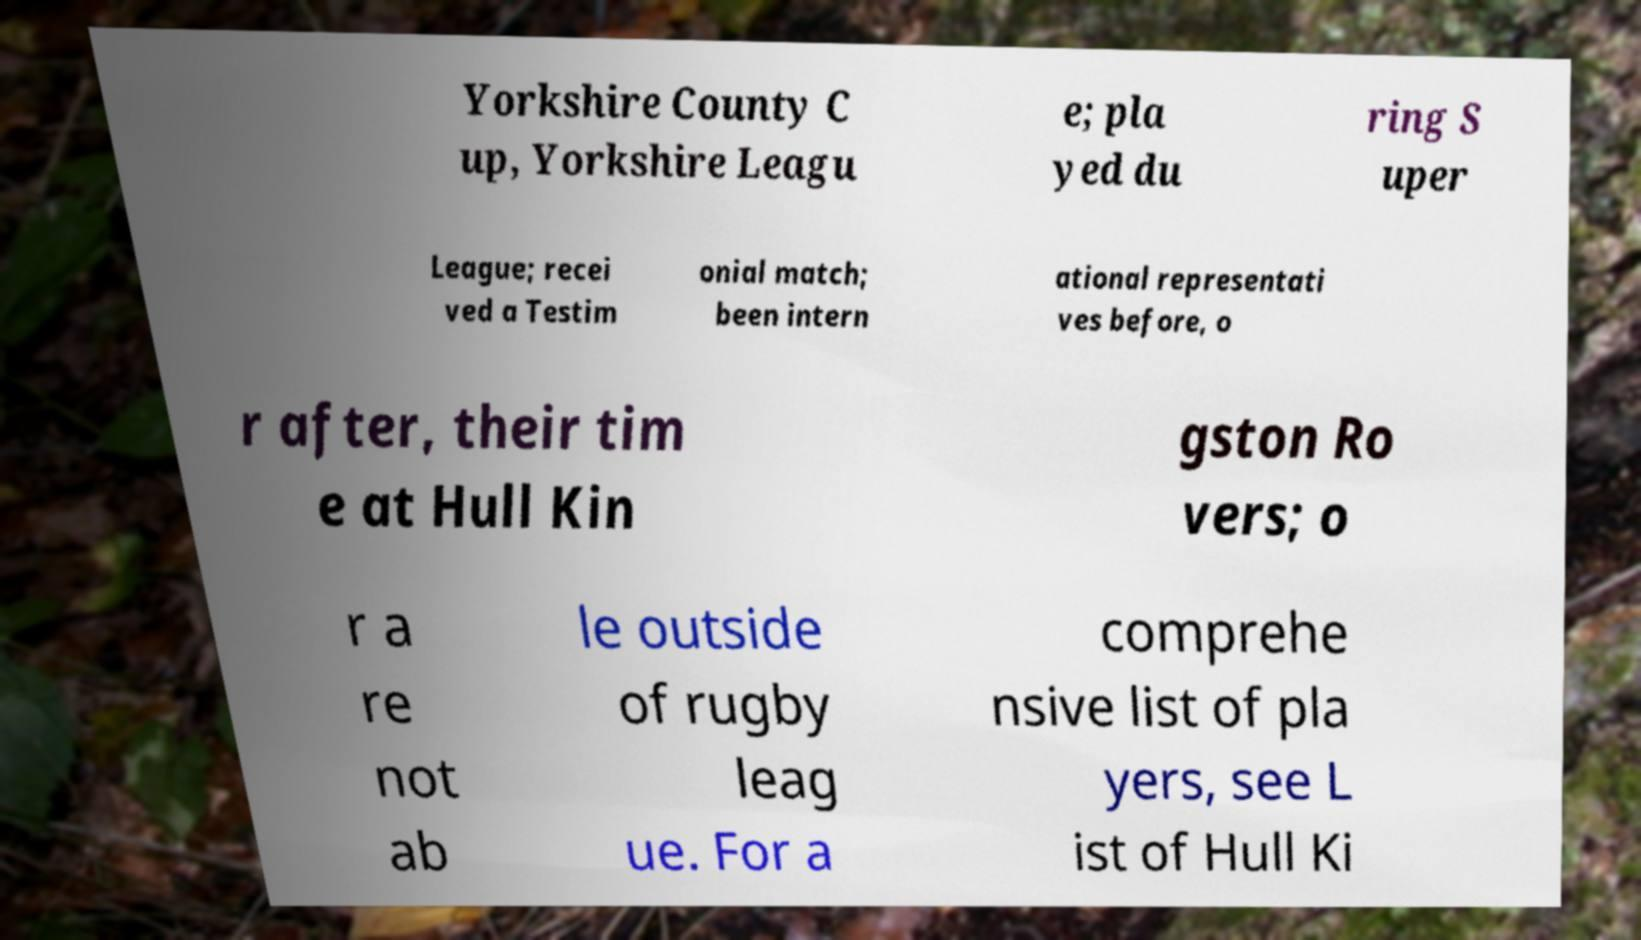What messages or text are displayed in this image? I need them in a readable, typed format. Yorkshire County C up, Yorkshire Leagu e; pla yed du ring S uper League; recei ved a Testim onial match; been intern ational representati ves before, o r after, their tim e at Hull Kin gston Ro vers; o r a re not ab le outside of rugby leag ue. For a comprehe nsive list of pla yers, see L ist of Hull Ki 